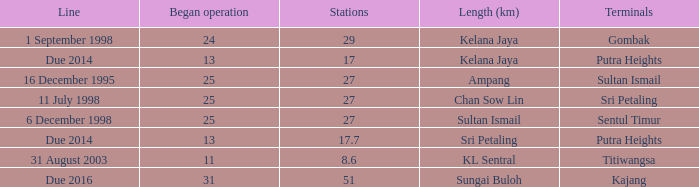Could you parse the entire table as a dict? {'header': ['Line', 'Began operation', 'Stations', 'Length (km)', 'Terminals'], 'rows': [['1 September 1998', '24', '29', 'Kelana Jaya', 'Gombak'], ['Due 2014', '13', '17', 'Kelana Jaya', 'Putra Heights'], ['16 December 1995', '25', '27', 'Ampang', 'Sultan Ismail'], ['11 July 1998', '25', '27', 'Chan Sow Lin', 'Sri Petaling'], ['6 December 1998', '25', '27', 'Sultan Ismail', 'Sentul Timur'], ['Due 2014', '13', '17.7', 'Sri Petaling', 'Putra Heights'], ['31 August 2003', '11', '8.6', 'KL Sentral', 'Titiwangsa'], ['Due 2016', '31', '51', 'Sungai Buloh', 'Kajang']]} When is the earliest began operation with a length of sultan ismail and over 27 stations? None. 